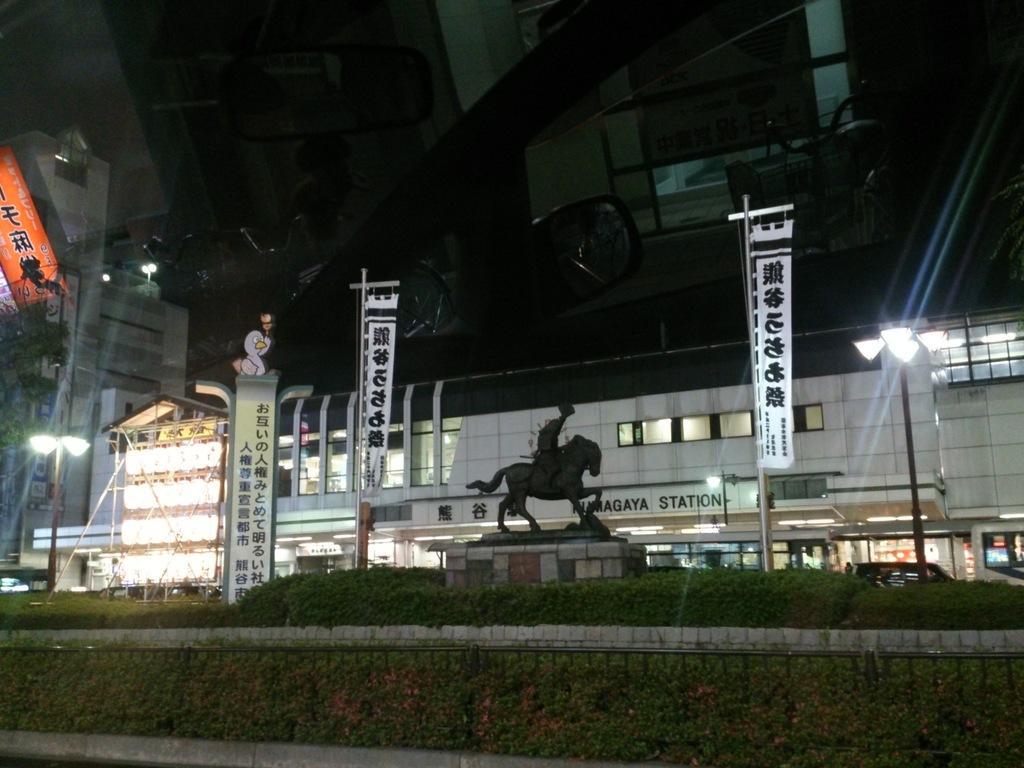In one or two sentences, can you explain what this image depicts? In this image there is grass, plants, buildings, lights, poles, and in the background there is sky. 